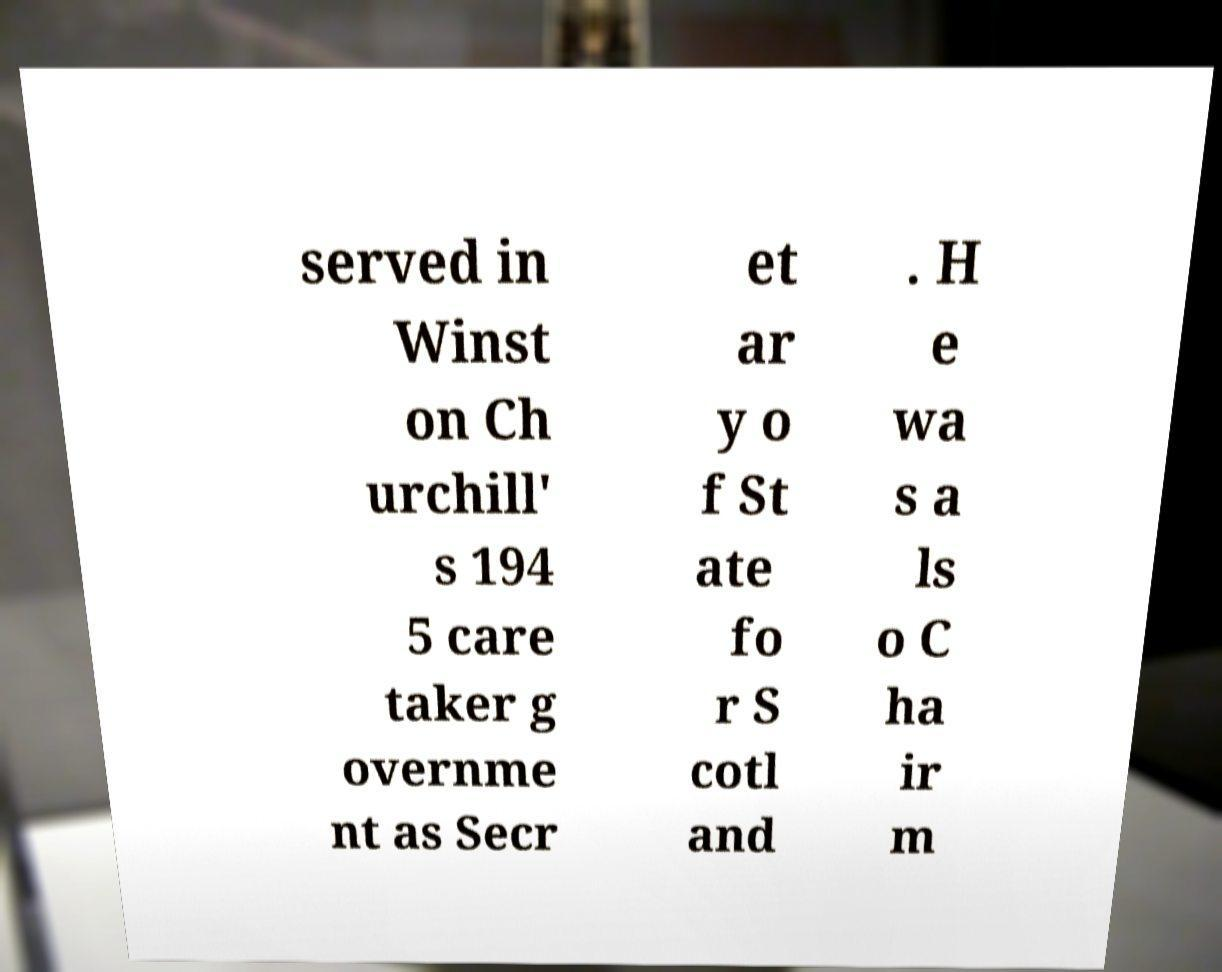Could you assist in decoding the text presented in this image and type it out clearly? served in Winst on Ch urchill' s 194 5 care taker g overnme nt as Secr et ar y o f St ate fo r S cotl and . H e wa s a ls o C ha ir m 